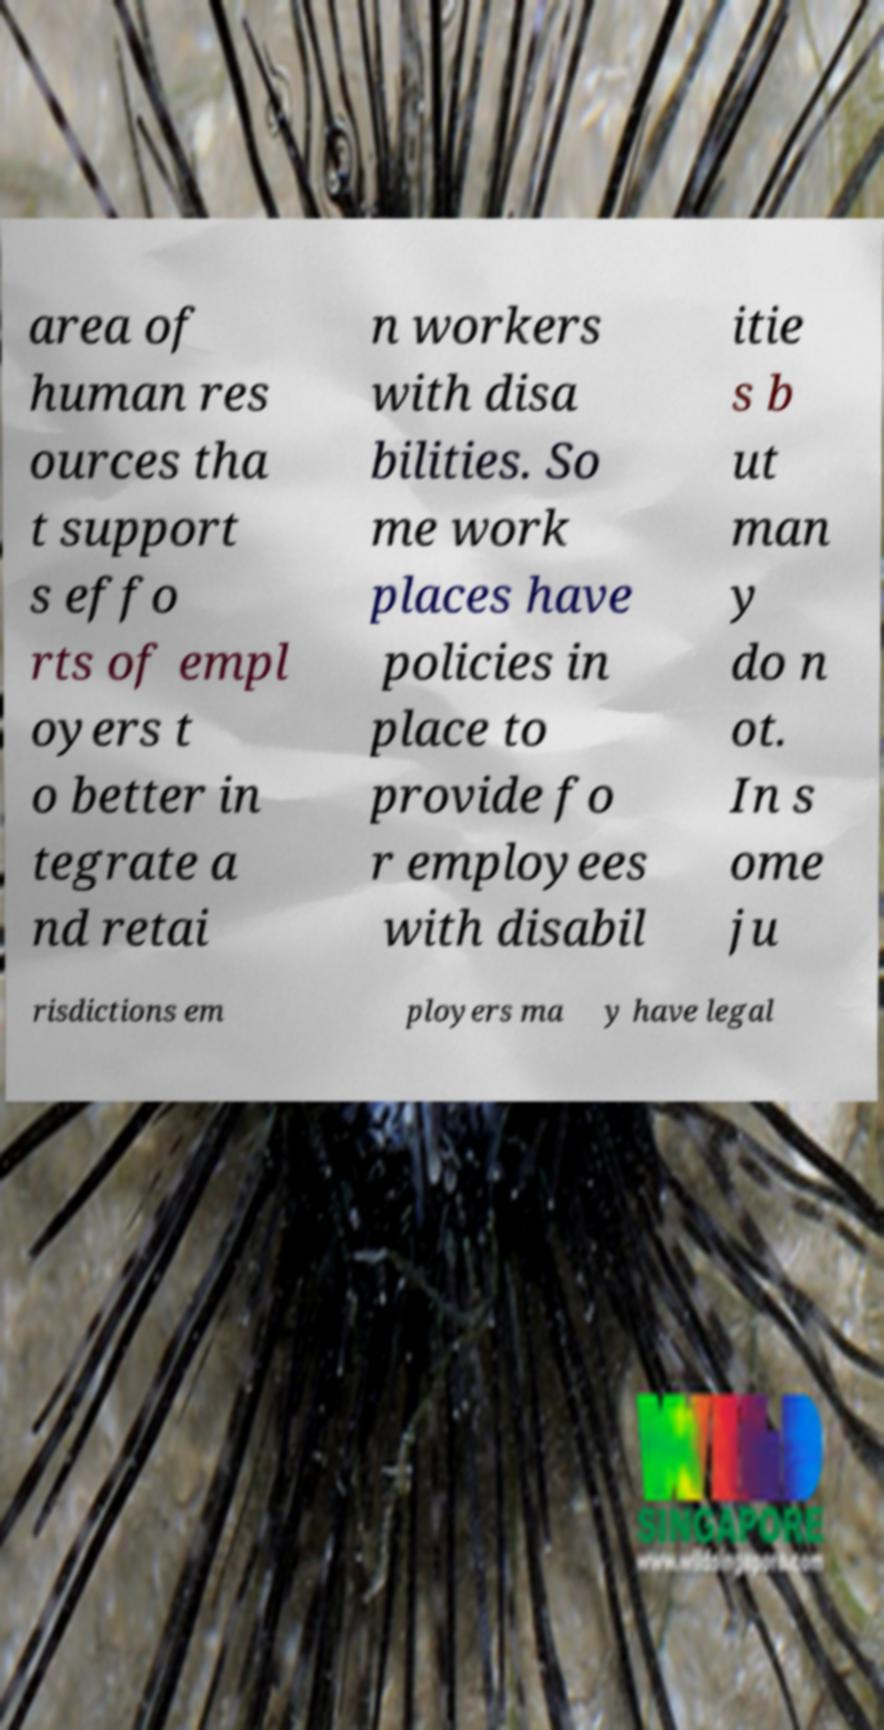There's text embedded in this image that I need extracted. Can you transcribe it verbatim? area of human res ources tha t support s effo rts of empl oyers t o better in tegrate a nd retai n workers with disa bilities. So me work places have policies in place to provide fo r employees with disabil itie s b ut man y do n ot. In s ome ju risdictions em ployers ma y have legal 